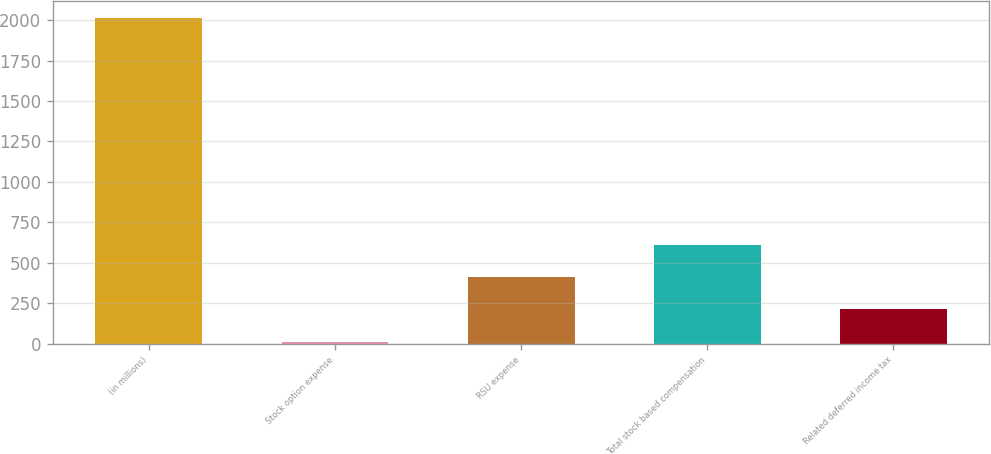<chart> <loc_0><loc_0><loc_500><loc_500><bar_chart><fcel>(in millions)<fcel>Stock option expense<fcel>RSU expense<fcel>Total stock based compensation<fcel>Related deferred income tax<nl><fcel>2016<fcel>10.6<fcel>411.68<fcel>612.22<fcel>211.14<nl></chart> 